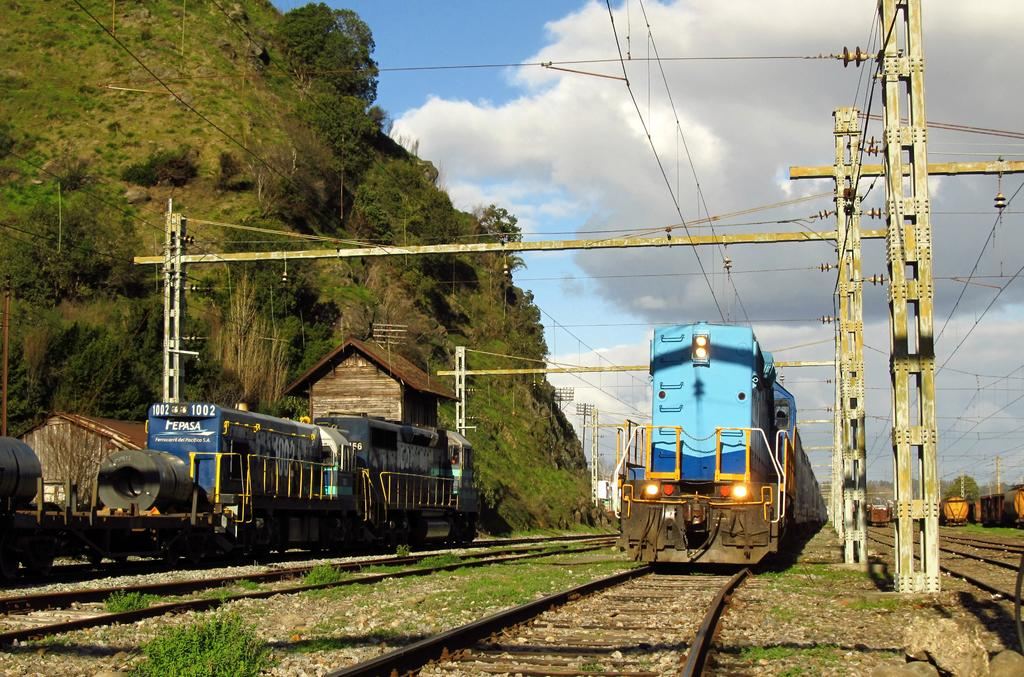What can be seen on the railway tracks in the image? There are trains on the railway tracks in the image. What type of structures are present in the image? There are houses in the image. What type of vegetation is present in the image? There are plants and trees in the image. What type of man-made structures are present in the image? There are poles in the image. What are the poles supporting in the image? The poles are supporting cables in the image. What is visible in the background of the image? The sky is visible in the background of the image. What type of beast is pulling the train in the image? There are no beasts present in the image; the trains are powered by engines. Is there a jail visible in the image? There is no jail present in the image. 